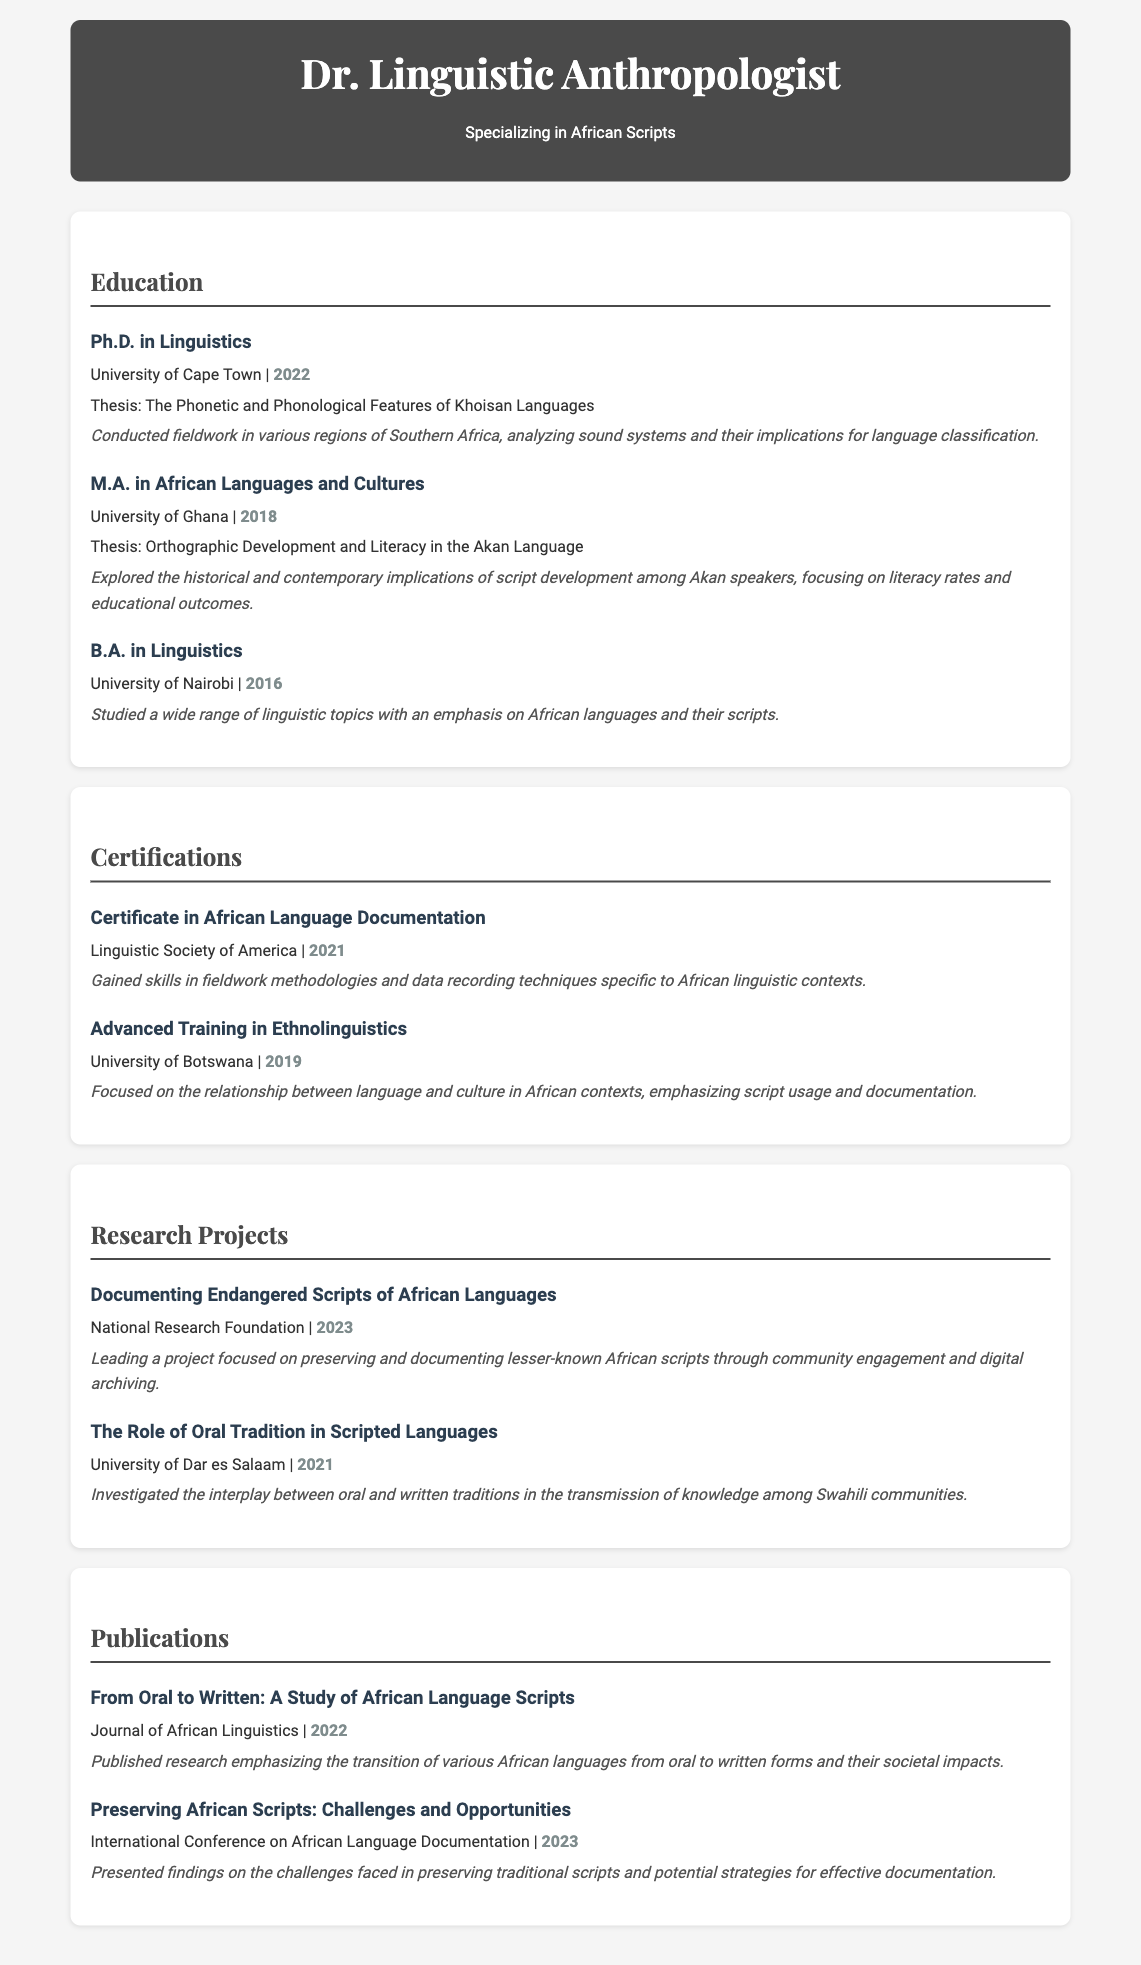What is the highest degree achieved? The highest degree mentioned in the document is the Ph.D. in Linguistics obtained from the University of Cape Town in 2022.
Answer: Ph.D. in Linguistics What is the thesis topic for the M.A. degree? The thesis topic for the M.A. in African Languages and Cultures is indicated in the document as Orthographic Development and Literacy in the Akan Language.
Answer: Orthographic Development and Literacy in the Akan Language In which year was the Certificate in African Language Documentation obtained? The year of obtaining the Certificate in African Language Documentation can be found in the Certifications section, which is 2021.
Answer: 2021 Which university did the individual attend for their undergraduate studies? The undergraduate studies were completed at the University of Nairobi, as stated in the document.
Answer: University of Nairobi What is the focus of the research project conducted in 2023? The focus of the research project documented in 2023 is on preserving and documenting lesser-known African scripts.
Answer: Preserving and documenting lesser-known African scripts Which journal published a study in 2022? The document specifies that the Journal of African Linguistics published a study in 2022, highlighting the transition of African languages from oral to written forms.
Answer: Journal of African Linguistics How many research projects are listed in the document? The number of research projects listed can be counted directly from the document's Research Projects section; there are two projects mentioned.
Answer: 2 What certification was obtained in 2019? The document clearly states that Advanced Training in Ethnolinguistics was received in 2019.
Answer: Advanced Training in Ethnolinguistics What was the main theme of the thesis for the Ph.D. degree? The main theme of the thesis for the Ph.D. degree is outlined as the Phonetic and Phonological Features of Khoisan Languages.
Answer: The Phonetic and Phonological Features of Khoisan Languages 